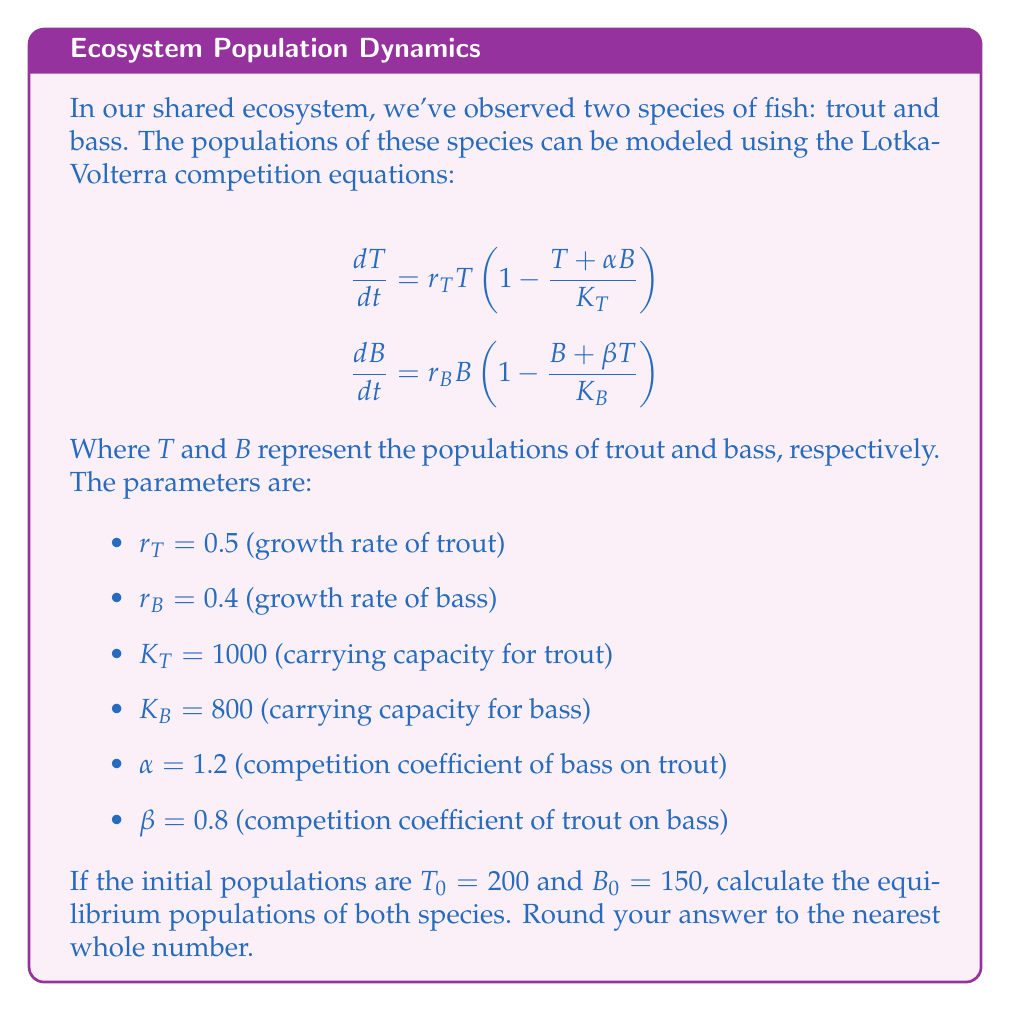What is the answer to this math problem? To find the equilibrium populations, we need to set both equations equal to zero and solve for $T$ and $B$. At equilibrium:

$$0 = r_T T \left(1 - \frac{T + \alpha B}{K_T}\right)$$
$$0 = r_B B \left(1 - \frac{B + \beta T}{K_B}\right)$$

Assuming non-zero populations, we can simplify:

$$1 - \frac{T + \alpha B}{K_T} = 0$$
$$1 - \frac{B + \beta T}{K_B} = 0$$

Rearranging:

$$T + \alpha B = K_T$$
$$B + \beta T = K_B$$

Substituting the given values:

$$T + 1.2B = 1000$$
$$B + 0.8T = 800$$

Now we have a system of two linear equations. Let's solve using substitution:

From the second equation:
$$B = 800 - 0.8T$$

Substituting into the first equation:

$$T + 1.2(800 - 0.8T) = 1000$$
$$T + 960 - 0.96T = 1000$$
$$0.04T = 40$$
$$T = 1000$$

Now we can find $B$:

$$B = 800 - 0.8(1000) = 0$$

However, this result suggests that the bass population would go extinct, which is not a stable equilibrium in this model. Let's verify the other possibility where trout goes extinct:

If $T = 0$, then from the second equation:
$$B = K_B = 800$$

Checking if this satisfies the first equation:
$$0 + 1.2(800) = 960 < 1000$$

This means that when bass reaches its carrying capacity, it prevents trout from establishing a population.

Therefore, the stable equilibrium is:

$T = 0$ (trout extinct)
$B = 800$ (bass at carrying capacity)
Answer: Trout: 0, Bass: 800 